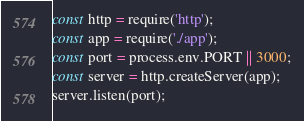Convert code to text. <code><loc_0><loc_0><loc_500><loc_500><_JavaScript_>const http = require('http');
const app = require('./app');
const port = process.env.PORT || 3000;
const server = http.createServer(app);
server.listen(port);
</code> 